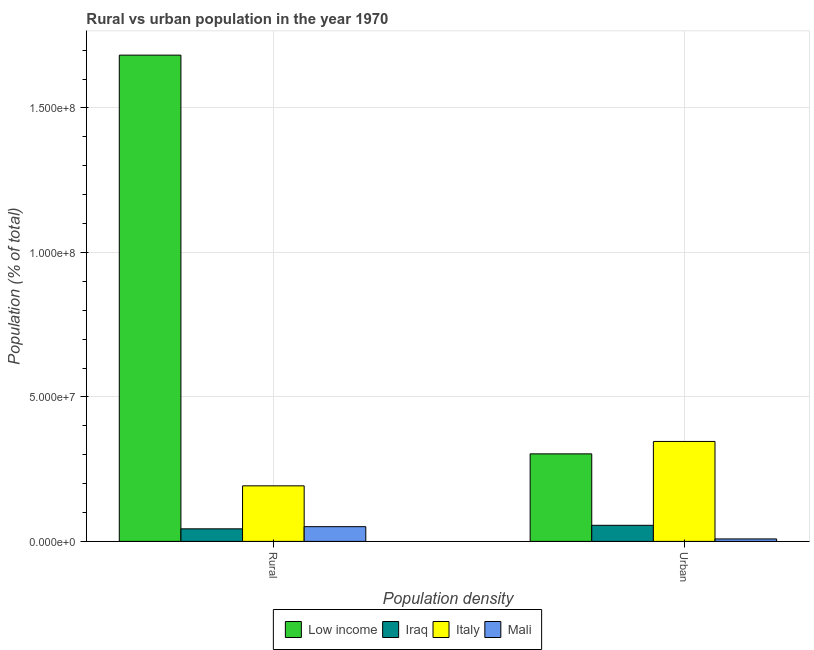How many bars are there on the 1st tick from the left?
Provide a short and direct response. 4. How many bars are there on the 1st tick from the right?
Provide a succinct answer. 4. What is the label of the 1st group of bars from the left?
Offer a very short reply. Rural. What is the rural population density in Mali?
Offer a very short reply. 5.10e+06. Across all countries, what is the maximum rural population density?
Provide a succinct answer. 1.68e+08. Across all countries, what is the minimum urban population density?
Offer a very short reply. 8.52e+05. In which country was the rural population density maximum?
Ensure brevity in your answer.  Low income. In which country was the rural population density minimum?
Keep it short and to the point. Iraq. What is the total urban population density in the graph?
Provide a short and direct response. 7.13e+07. What is the difference between the urban population density in Mali and that in Low income?
Give a very brief answer. -2.94e+07. What is the difference between the rural population density in Iraq and the urban population density in Low income?
Provide a succinct answer. -2.59e+07. What is the average rural population density per country?
Offer a very short reply. 4.92e+07. What is the difference between the rural population density and urban population density in Low income?
Make the answer very short. 1.38e+08. What is the ratio of the urban population density in Italy to that in Mali?
Your response must be concise. 40.58. In how many countries, is the urban population density greater than the average urban population density taken over all countries?
Keep it short and to the point. 2. What does the 1st bar from the left in Urban represents?
Keep it short and to the point. Low income. What does the 1st bar from the right in Rural represents?
Make the answer very short. Mali. What is the difference between two consecutive major ticks on the Y-axis?
Offer a terse response. 5.00e+07. Are the values on the major ticks of Y-axis written in scientific E-notation?
Your answer should be compact. Yes. Does the graph contain any zero values?
Offer a very short reply. No. Does the graph contain grids?
Your answer should be very brief. Yes. How are the legend labels stacked?
Ensure brevity in your answer.  Horizontal. What is the title of the graph?
Your response must be concise. Rural vs urban population in the year 1970. What is the label or title of the X-axis?
Offer a very short reply. Population density. What is the label or title of the Y-axis?
Keep it short and to the point. Population (% of total). What is the Population (% of total) in Low income in Rural?
Keep it short and to the point. 1.68e+08. What is the Population (% of total) in Iraq in Rural?
Keep it short and to the point. 4.35e+06. What is the Population (% of total) of Italy in Rural?
Offer a terse response. 1.92e+07. What is the Population (% of total) in Mali in Rural?
Your response must be concise. 5.10e+06. What is the Population (% of total) of Low income in Urban?
Ensure brevity in your answer.  3.03e+07. What is the Population (% of total) in Iraq in Urban?
Provide a succinct answer. 5.57e+06. What is the Population (% of total) of Italy in Urban?
Provide a succinct answer. 3.46e+07. What is the Population (% of total) in Mali in Urban?
Offer a terse response. 8.52e+05. Across all Population density, what is the maximum Population (% of total) in Low income?
Your answer should be very brief. 1.68e+08. Across all Population density, what is the maximum Population (% of total) in Iraq?
Ensure brevity in your answer.  5.57e+06. Across all Population density, what is the maximum Population (% of total) in Italy?
Provide a succinct answer. 3.46e+07. Across all Population density, what is the maximum Population (% of total) in Mali?
Your answer should be compact. 5.10e+06. Across all Population density, what is the minimum Population (% of total) in Low income?
Your answer should be very brief. 3.03e+07. Across all Population density, what is the minimum Population (% of total) in Iraq?
Keep it short and to the point. 4.35e+06. Across all Population density, what is the minimum Population (% of total) of Italy?
Provide a short and direct response. 1.92e+07. Across all Population density, what is the minimum Population (% of total) in Mali?
Keep it short and to the point. 8.52e+05. What is the total Population (% of total) in Low income in the graph?
Your answer should be very brief. 1.99e+08. What is the total Population (% of total) in Iraq in the graph?
Ensure brevity in your answer.  9.92e+06. What is the total Population (% of total) in Italy in the graph?
Your answer should be very brief. 5.38e+07. What is the total Population (% of total) of Mali in the graph?
Offer a very short reply. 5.95e+06. What is the difference between the Population (% of total) in Low income in Rural and that in Urban?
Provide a succinct answer. 1.38e+08. What is the difference between the Population (% of total) in Iraq in Rural and that in Urban?
Offer a very short reply. -1.22e+06. What is the difference between the Population (% of total) of Italy in Rural and that in Urban?
Keep it short and to the point. -1.54e+07. What is the difference between the Population (% of total) in Mali in Rural and that in Urban?
Your response must be concise. 4.24e+06. What is the difference between the Population (% of total) in Low income in Rural and the Population (% of total) in Iraq in Urban?
Offer a terse response. 1.63e+08. What is the difference between the Population (% of total) in Low income in Rural and the Population (% of total) in Italy in Urban?
Offer a very short reply. 1.34e+08. What is the difference between the Population (% of total) in Low income in Rural and the Population (% of total) in Mali in Urban?
Make the answer very short. 1.67e+08. What is the difference between the Population (% of total) of Iraq in Rural and the Population (% of total) of Italy in Urban?
Give a very brief answer. -3.02e+07. What is the difference between the Population (% of total) of Iraq in Rural and the Population (% of total) of Mali in Urban?
Provide a short and direct response. 3.50e+06. What is the difference between the Population (% of total) of Italy in Rural and the Population (% of total) of Mali in Urban?
Your answer should be compact. 1.84e+07. What is the average Population (% of total) of Low income per Population density?
Provide a short and direct response. 9.93e+07. What is the average Population (% of total) in Iraq per Population density?
Provide a succinct answer. 4.96e+06. What is the average Population (% of total) of Italy per Population density?
Give a very brief answer. 2.69e+07. What is the average Population (% of total) of Mali per Population density?
Give a very brief answer. 2.97e+06. What is the difference between the Population (% of total) of Low income and Population (% of total) of Iraq in Rural?
Provide a succinct answer. 1.64e+08. What is the difference between the Population (% of total) in Low income and Population (% of total) in Italy in Rural?
Provide a short and direct response. 1.49e+08. What is the difference between the Population (% of total) in Low income and Population (% of total) in Mali in Rural?
Ensure brevity in your answer.  1.63e+08. What is the difference between the Population (% of total) in Iraq and Population (% of total) in Italy in Rural?
Offer a very short reply. -1.49e+07. What is the difference between the Population (% of total) in Iraq and Population (% of total) in Mali in Rural?
Give a very brief answer. -7.48e+05. What is the difference between the Population (% of total) of Italy and Population (% of total) of Mali in Rural?
Provide a short and direct response. 1.41e+07. What is the difference between the Population (% of total) in Low income and Population (% of total) in Iraq in Urban?
Make the answer very short. 2.47e+07. What is the difference between the Population (% of total) of Low income and Population (% of total) of Italy in Urban?
Your answer should be very brief. -4.30e+06. What is the difference between the Population (% of total) of Low income and Population (% of total) of Mali in Urban?
Your answer should be very brief. 2.94e+07. What is the difference between the Population (% of total) of Iraq and Population (% of total) of Italy in Urban?
Provide a succinct answer. -2.90e+07. What is the difference between the Population (% of total) in Iraq and Population (% of total) in Mali in Urban?
Ensure brevity in your answer.  4.72e+06. What is the difference between the Population (% of total) in Italy and Population (% of total) in Mali in Urban?
Provide a short and direct response. 3.37e+07. What is the ratio of the Population (% of total) in Low income in Rural to that in Urban?
Make the answer very short. 5.56. What is the ratio of the Population (% of total) in Iraq in Rural to that in Urban?
Give a very brief answer. 0.78. What is the ratio of the Population (% of total) in Italy in Rural to that in Urban?
Give a very brief answer. 0.56. What is the ratio of the Population (% of total) of Mali in Rural to that in Urban?
Make the answer very short. 5.98. What is the difference between the highest and the second highest Population (% of total) in Low income?
Your answer should be very brief. 1.38e+08. What is the difference between the highest and the second highest Population (% of total) of Iraq?
Make the answer very short. 1.22e+06. What is the difference between the highest and the second highest Population (% of total) in Italy?
Provide a short and direct response. 1.54e+07. What is the difference between the highest and the second highest Population (% of total) of Mali?
Ensure brevity in your answer.  4.24e+06. What is the difference between the highest and the lowest Population (% of total) of Low income?
Provide a succinct answer. 1.38e+08. What is the difference between the highest and the lowest Population (% of total) in Iraq?
Provide a short and direct response. 1.22e+06. What is the difference between the highest and the lowest Population (% of total) of Italy?
Keep it short and to the point. 1.54e+07. What is the difference between the highest and the lowest Population (% of total) of Mali?
Make the answer very short. 4.24e+06. 